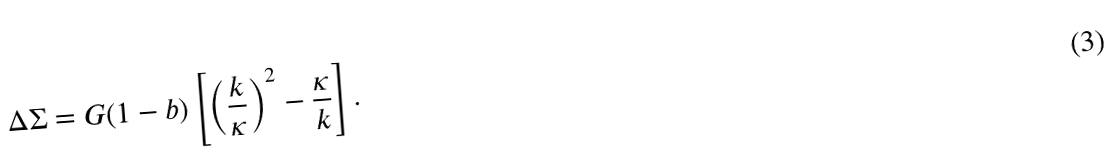Convert formula to latex. <formula><loc_0><loc_0><loc_500><loc_500>\Delta \Sigma = G ( 1 - b ) \left [ \left ( \frac { k } { \kappa } \right ) ^ { 2 } - \frac { \kappa } { k } \right ] .</formula> 